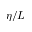Convert formula to latex. <formula><loc_0><loc_0><loc_500><loc_500>\eta / L</formula> 